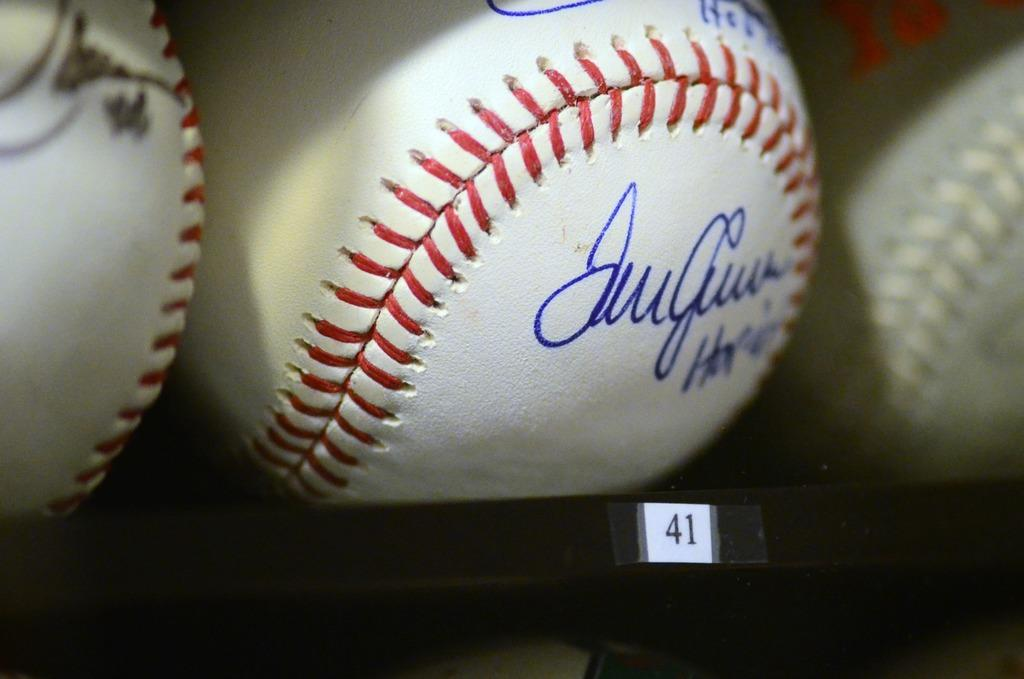Provide a one-sentence caption for the provided image. A signed baseball on a shelf with the labeling 41. 